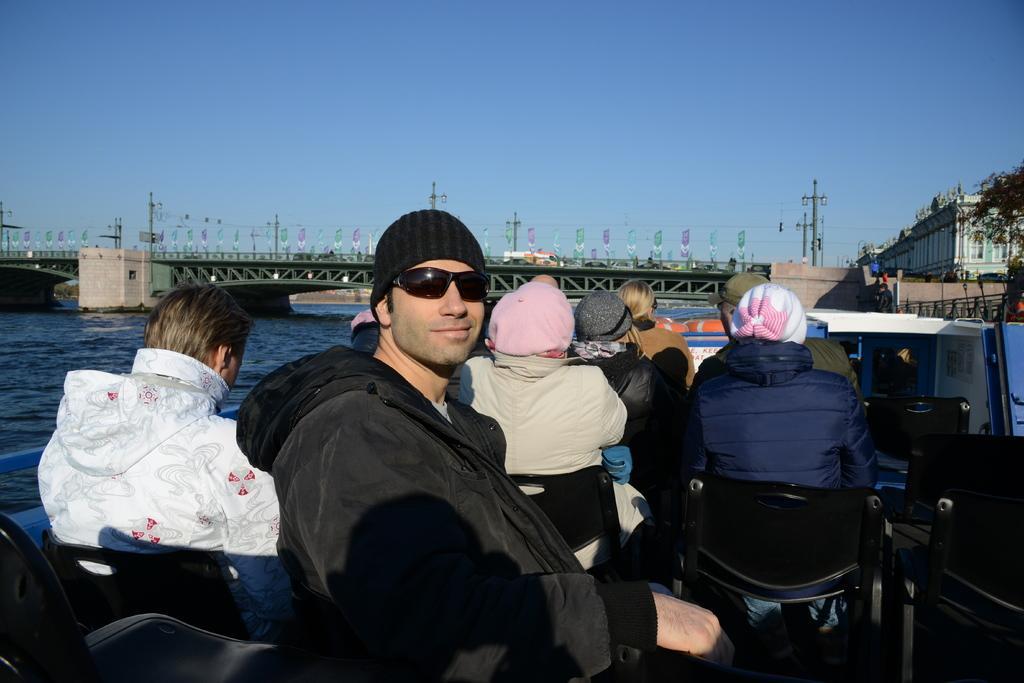In one or two sentences, can you explain what this image depicts? This is an outside view. Here I can see few people sitting on the boat facing towards the back side. Here I can see a man sitting on a chair facing towards the right side, wearing a jacket, cap on the head, smiling and giving pose for the picture. On the left side, I can see the water and there is a bridge. On the right side there is a building and trees and also I can see few light poles. At the top of the image I can see the sky in blue color. 